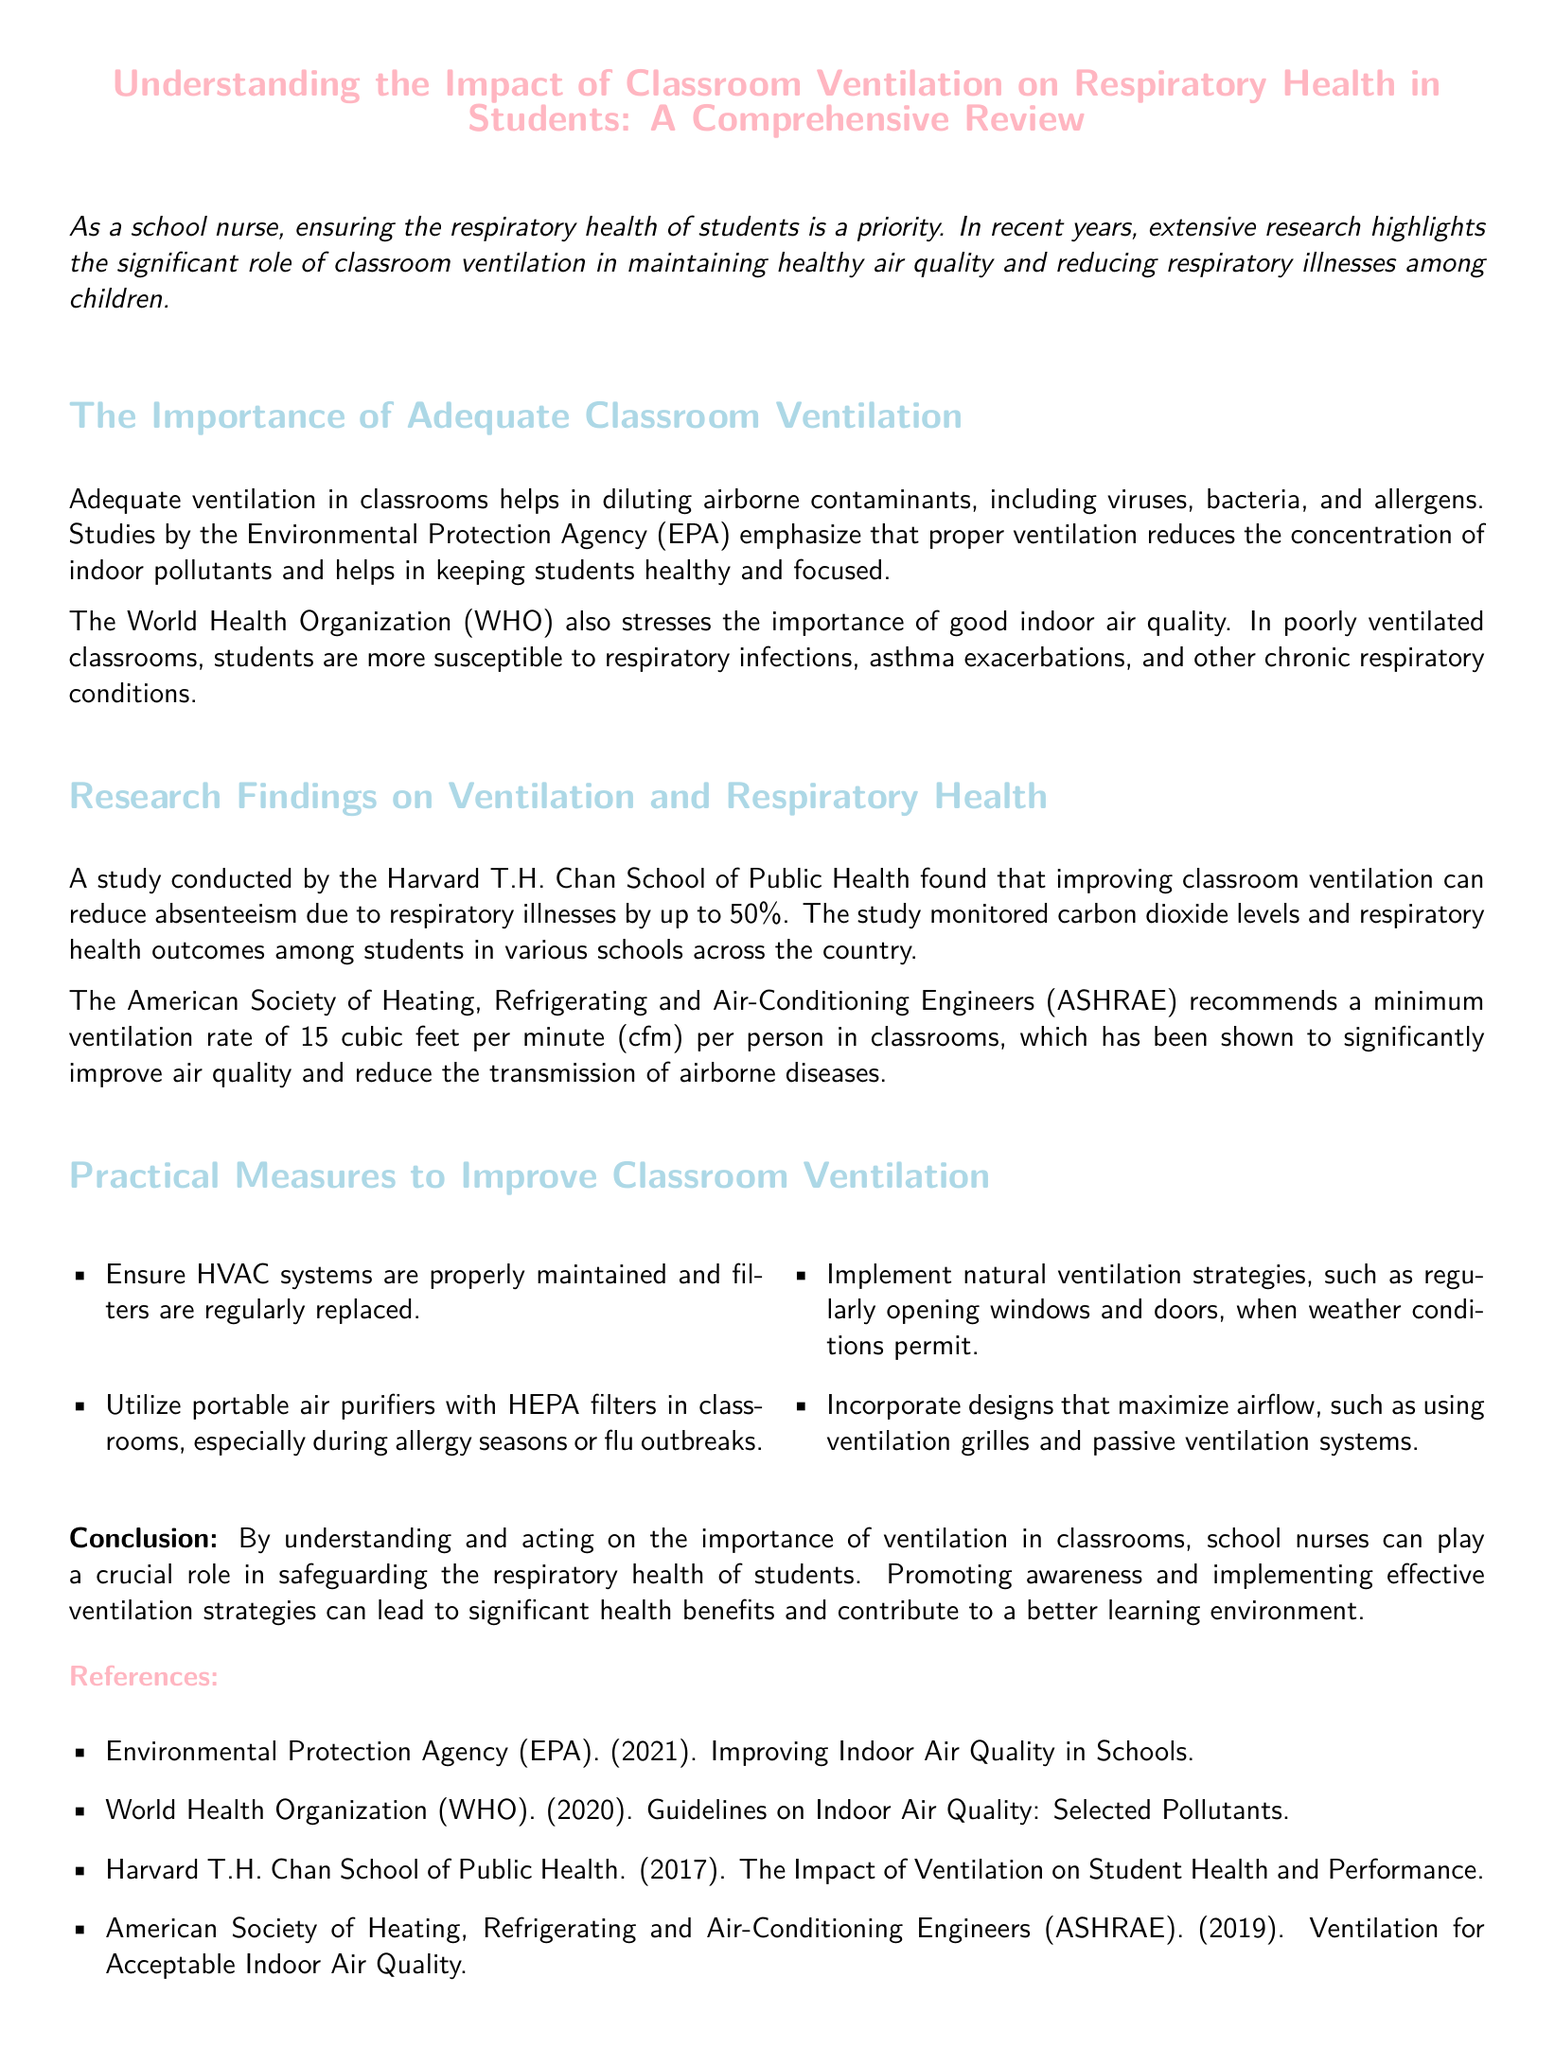What is the minimum ventilation rate recommended by ASHRAE? The document states that the American Society of Heating, Refrigerating and Air-Conditioning Engineers recommends a minimum ventilation rate of 15 cubic feet per minute (cfm) per person in classrooms.
Answer: 15 cubic feet per minute (cfm) What type of filters are suggested for portable air purifiers? The whitepaper recommends using portable air purifiers with HEPA filters in classrooms, especially during allergy seasons or flu outbreaks.
Answer: HEPA filters How much can improving classroom ventilation reduce absenteeism? According to the study by the Harvard T.H. Chan School of Public Health, improving classroom ventilation can reduce absenteeism due to respiratory illnesses by up to 50%.
Answer: 50% What organization emphasizes the role of good indoor air quality? The World Health Organization emphasizes the importance of good indoor air quality in the document.
Answer: World Health Organization What action can be taken to improve ventilation related to HVAC systems? The document mentions that one practical measure to improve classroom ventilation is to ensure HVAC systems are properly maintained and filters are regularly replaced.
Answer: Maintain HVAC systems Why is classroom ventilation important for students? The comprehensive review highlights that adequate ventilation helps in diluting airborne contaminants, which reduces susceptibility to respiratory infections and asthma exacerbations in students.
Answer: Reduces respiratory infections and asthma exacerbations What is the role of school nurses according to the conclusion? The conclusion states that school nurses can play a crucial role in safeguarding the respiratory health of students by promoting awareness and implementing effective ventilation strategies.
Answer: Safeguarding respiratory health 